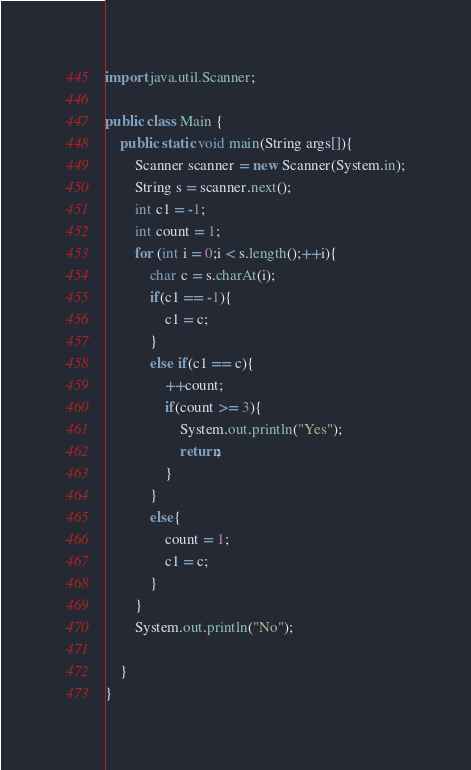Convert code to text. <code><loc_0><loc_0><loc_500><loc_500><_Java_>import java.util.Scanner;

public class Main {
    public static void main(String args[]){
        Scanner scanner = new Scanner(System.in);
        String s = scanner.next();
        int c1 = -1;
        int count = 1;
        for (int i = 0;i < s.length();++i){
            char c = s.charAt(i);
            if(c1 == -1){
                c1 = c;
            }
            else if(c1 == c){
                ++count;
                if(count >= 3){
                    System.out.println("Yes");
                    return;
                }
            }
            else{
                count = 1;
                c1 = c;
            }
        }
        System.out.println("No");

    }
}</code> 